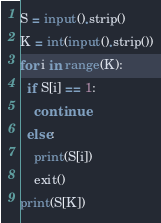Convert code to text. <code><loc_0><loc_0><loc_500><loc_500><_Python_>S = input().strip()
K = int(input().strip())
for i in range(K):
  if S[i] == 1:
    continue
  else:
    print(S[i])
    exit()
print(S[K])</code> 